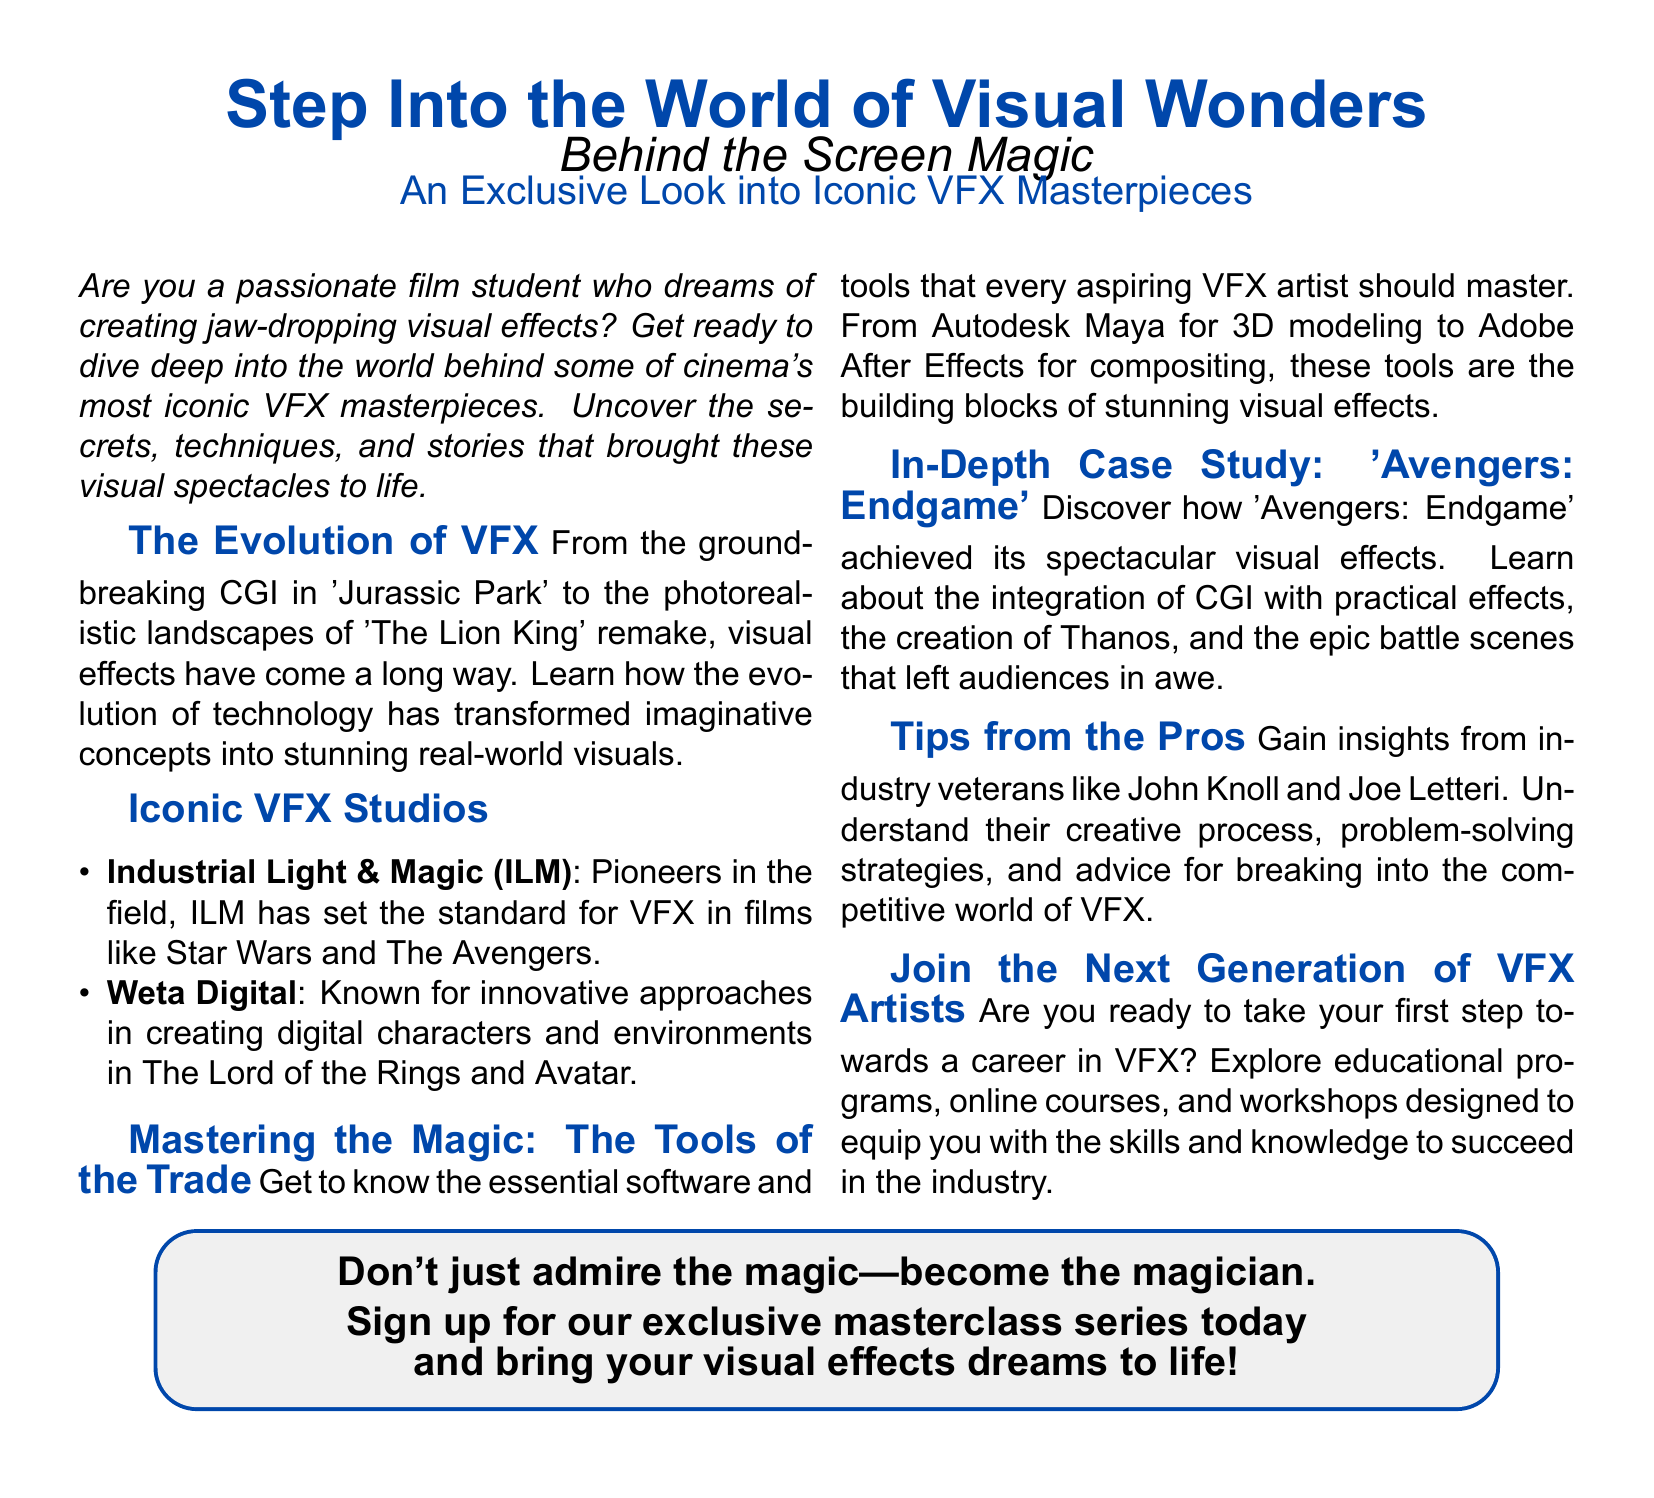What is the title of the advertisement? The title of the advertisement is prominently displayed at the top of the document.
Answer: Step Into the World of Visual Wonders What iconic film is mentioned in relation to groundbreaking CGI? This film is referenced to illustrate the evolution of visual effects.
Answer: Jurassic Park Which VFX studio is known for work on The Lord of the Rings? The document lists two iconic VFX studios, one of which is recognized for this work.
Answer: Weta Digital What software is used for 3D modeling according to the document? The document specifies essential tools for VFX artists, including one for 3D modeling.
Answer: Autodesk Maya What is the main subject of the in-depth case study? This case study is highlighted in the advertisement as an example of stunning visual effects.
Answer: Avengers: Endgame Who are two industry veterans mentioned in the document? Their insights are offered in the section discussing tips for aspiring VFX artists.
Answer: John Knoll and Joe Letteri What is offered for those interested in pursuing VFX careers? This section indicates resources available for aspiring artists to enhance their skills.
Answer: Educational programs What is the call to action at the end of the document? The advertisement concludes with a motivating prompt for readers regarding their future in VFX.
Answer: Sign up for our exclusive masterclass series today 